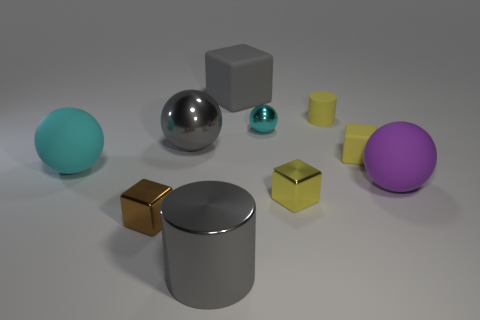Does the gray block have the same size as the cyan metallic object?
Your answer should be very brief. No. What number of other objects are the same size as the purple ball?
Offer a very short reply. 4. How many objects are either gray objects in front of the big gray matte block or rubber objects that are in front of the gray metal ball?
Offer a very short reply. 5. There is a purple object that is the same size as the gray matte thing; what is its shape?
Your answer should be compact. Sphere. There is a brown block that is the same material as the gray sphere; what is its size?
Make the answer very short. Small. Is the shape of the cyan rubber thing the same as the large purple rubber object?
Provide a succinct answer. Yes. What color is the metallic ball that is the same size as the gray cube?
Give a very brief answer. Gray. What size is the gray thing that is the same shape as the big cyan matte thing?
Offer a terse response. Large. There is a large thing to the right of the rubber cylinder; what is its shape?
Provide a short and direct response. Sphere. There is a cyan metal object; is it the same shape as the large shiny thing in front of the tiny matte block?
Offer a very short reply. No. 